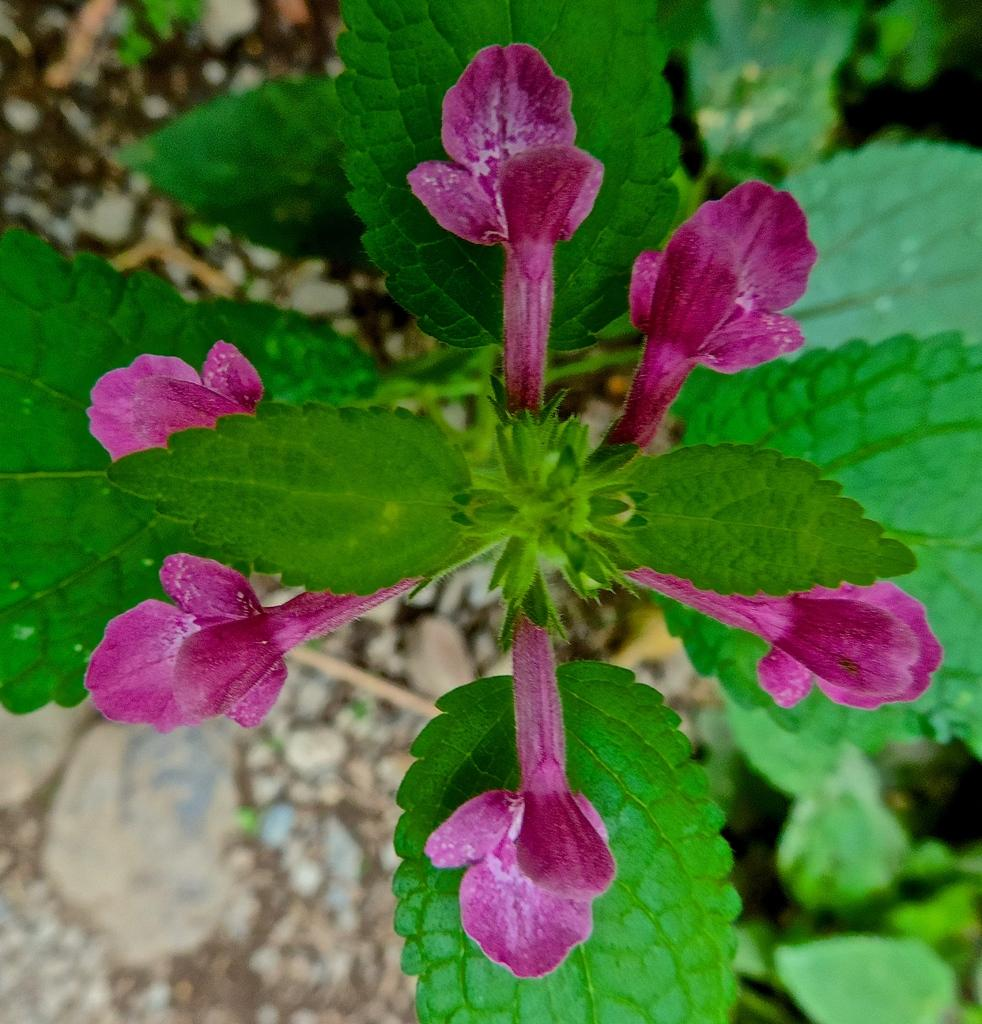What type of plants can be seen in the image? There are plants with flowers in the image. What else is present on the surface in the image? There are stones on the surface in the image. What color is the dress worn by the horse in the image? There are no horses or dresses present in the image. 